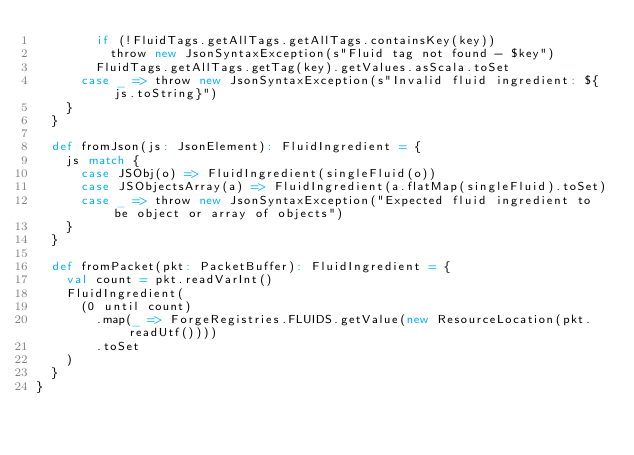Convert code to text. <code><loc_0><loc_0><loc_500><loc_500><_Scala_>        if (!FluidTags.getAllTags.getAllTags.containsKey(key))
          throw new JsonSyntaxException(s"Fluid tag not found - $key")
        FluidTags.getAllTags.getTag(key).getValues.asScala.toSet
      case _ => throw new JsonSyntaxException(s"Invalid fluid ingredient: ${js.toString}")
    }
  }

  def fromJson(js: JsonElement): FluidIngredient = {
    js match {
      case JSObj(o) => FluidIngredient(singleFluid(o))
      case JSObjectsArray(a) => FluidIngredient(a.flatMap(singleFluid).toSet)
      case _ => throw new JsonSyntaxException("Expected fluid ingredient to be object or array of objects")
    }
  }

  def fromPacket(pkt: PacketBuffer): FluidIngredient = {
    val count = pkt.readVarInt()
    FluidIngredient(
      (0 until count)
        .map(_ => ForgeRegistries.FLUIDS.getValue(new ResourceLocation(pkt.readUtf())))
        .toSet
    )
  }
}</code> 